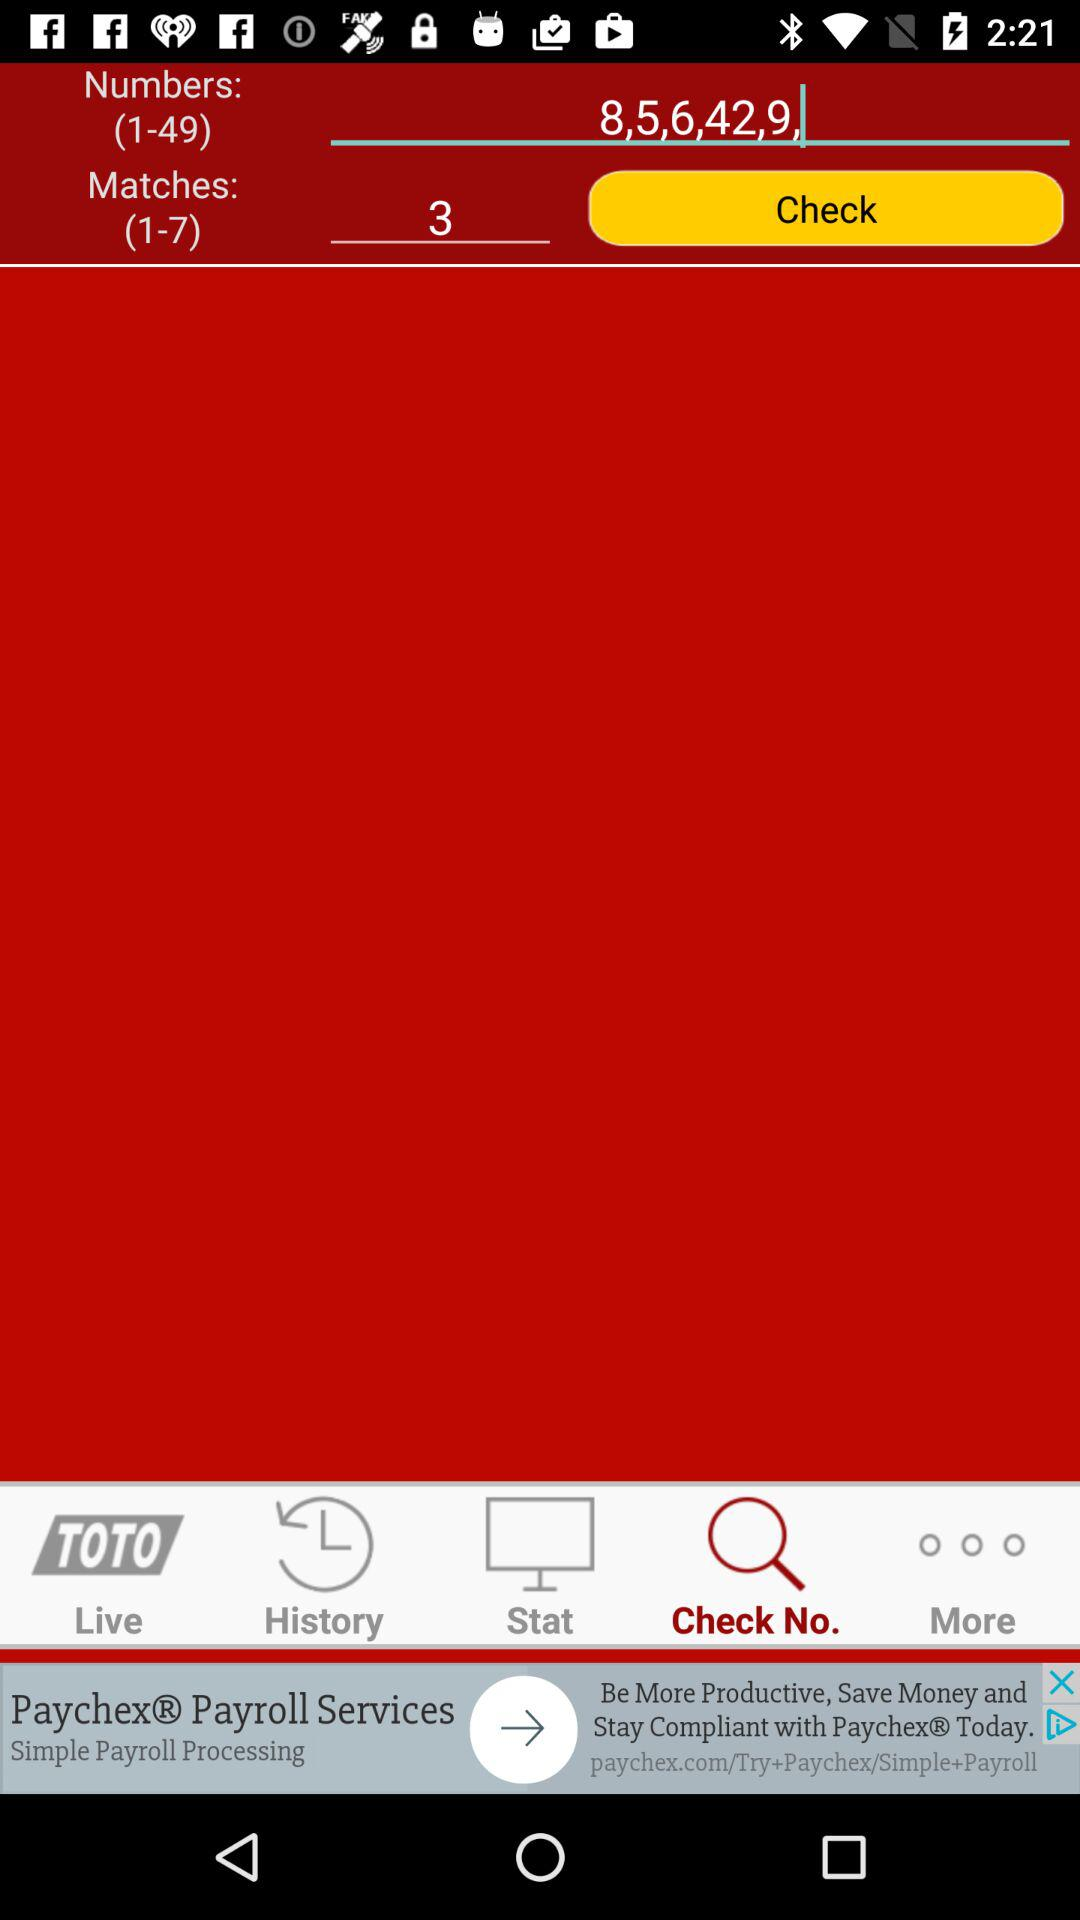Which match number is selected? The selected match number is 3. 